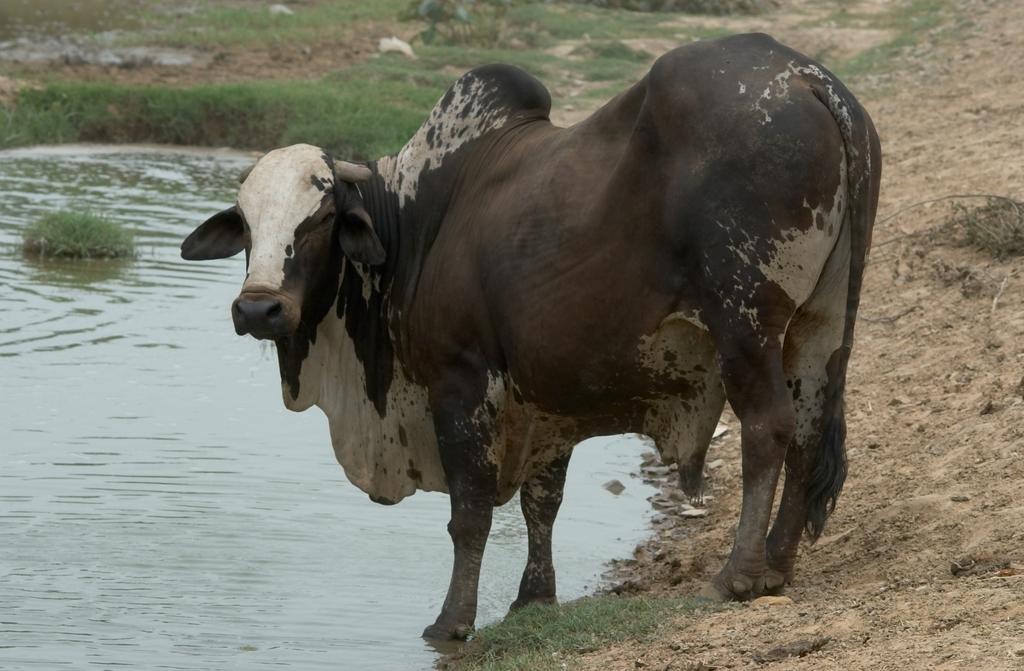Could you give a brief overview of what you see in this image? In this picture I can see an animal in front, which is of black and white in color and it is on the ground. On the left side of this picture I can see the water. In the background I can see the grass. 